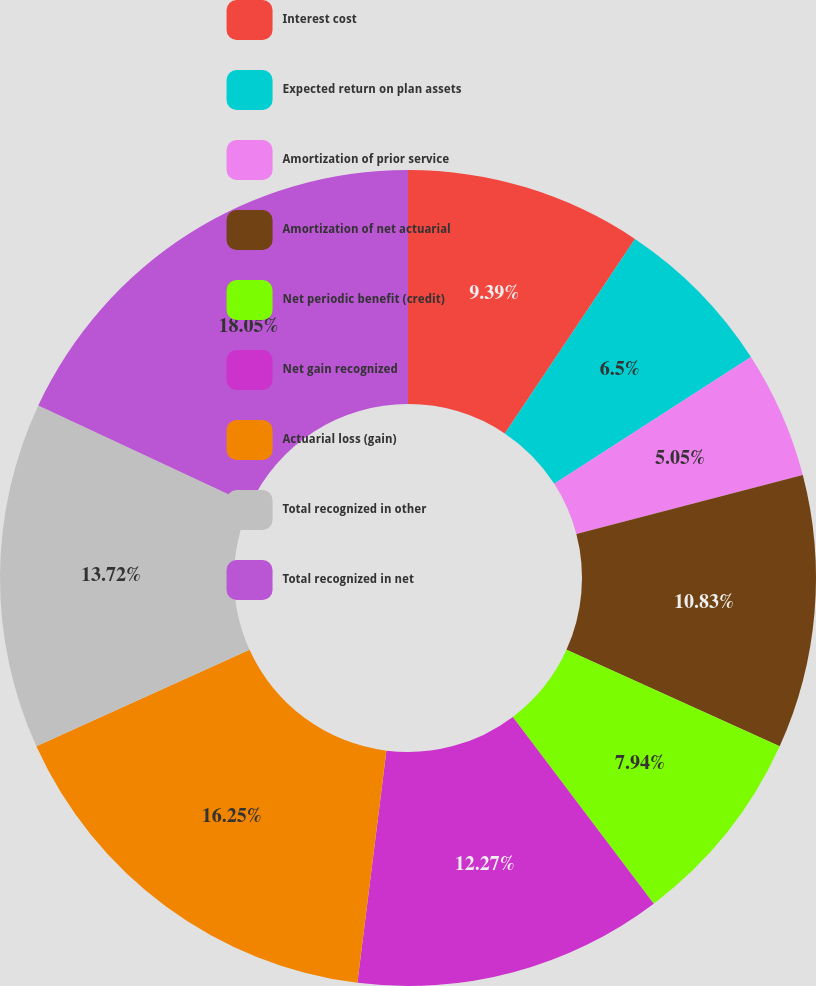Convert chart to OTSL. <chart><loc_0><loc_0><loc_500><loc_500><pie_chart><fcel>Interest cost<fcel>Expected return on plan assets<fcel>Amortization of prior service<fcel>Amortization of net actuarial<fcel>Net periodic benefit (credit)<fcel>Net gain recognized<fcel>Actuarial loss (gain)<fcel>Total recognized in other<fcel>Total recognized in net<nl><fcel>9.39%<fcel>6.5%<fcel>5.05%<fcel>10.83%<fcel>7.94%<fcel>12.27%<fcel>16.25%<fcel>13.72%<fcel>18.05%<nl></chart> 